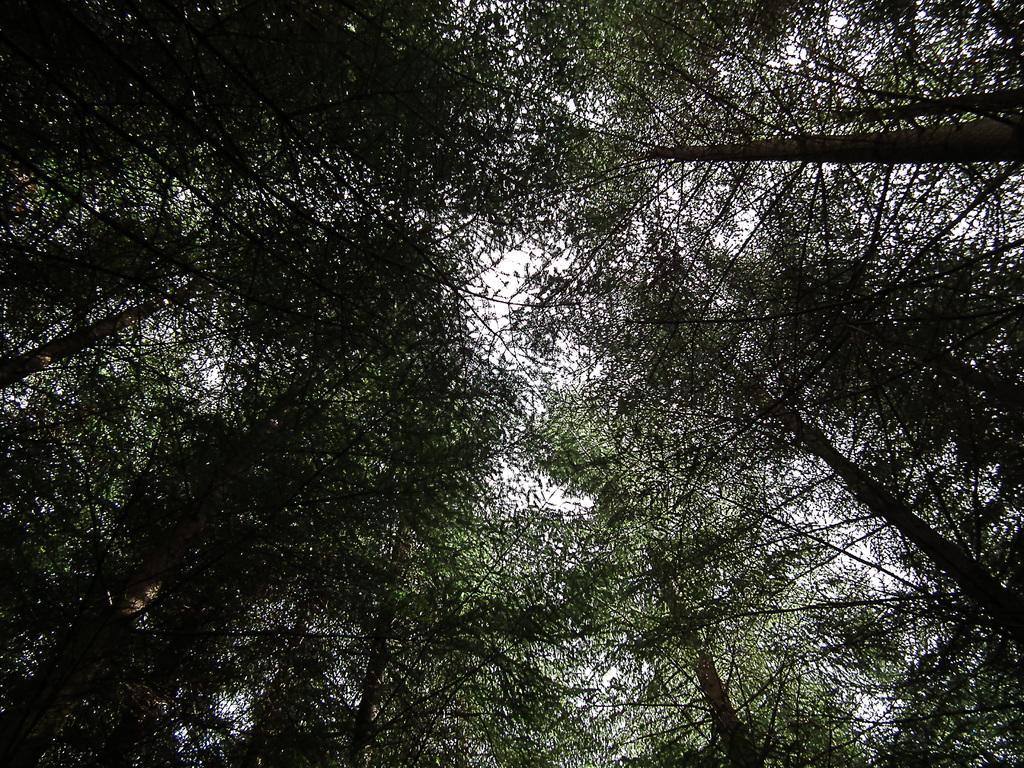Can you describe this image briefly? In this image I can see the trees. At the top I can see the sky. 